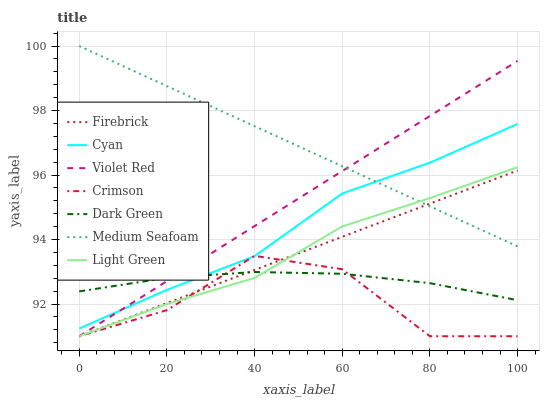Does Crimson have the minimum area under the curve?
Answer yes or no. Yes. Does Medium Seafoam have the maximum area under the curve?
Answer yes or no. Yes. Does Firebrick have the minimum area under the curve?
Answer yes or no. No. Does Firebrick have the maximum area under the curve?
Answer yes or no. No. Is Violet Red the smoothest?
Answer yes or no. Yes. Is Crimson the roughest?
Answer yes or no. Yes. Is Firebrick the smoothest?
Answer yes or no. No. Is Firebrick the roughest?
Answer yes or no. No. Does Violet Red have the lowest value?
Answer yes or no. Yes. Does Cyan have the lowest value?
Answer yes or no. No. Does Medium Seafoam have the highest value?
Answer yes or no. Yes. Does Firebrick have the highest value?
Answer yes or no. No. Is Dark Green less than Medium Seafoam?
Answer yes or no. Yes. Is Cyan greater than Light Green?
Answer yes or no. Yes. Does Dark Green intersect Cyan?
Answer yes or no. Yes. Is Dark Green less than Cyan?
Answer yes or no. No. Is Dark Green greater than Cyan?
Answer yes or no. No. Does Dark Green intersect Medium Seafoam?
Answer yes or no. No. 